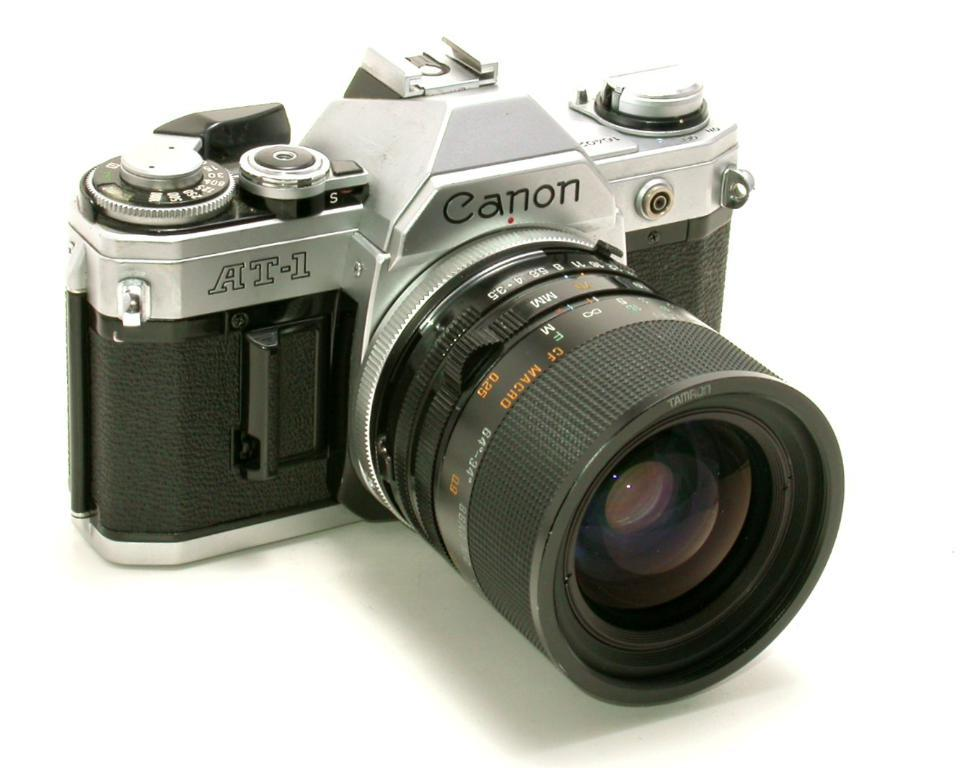What is the main object in the image? There is a camera in the image. What colors are visible on the camera? The camera is black and gray in color. What is the background of the image? There is a white background in the image. How many men can be seen working in the industry in the image? There are no men or industries present in the image; it only features a camera on a white background. 